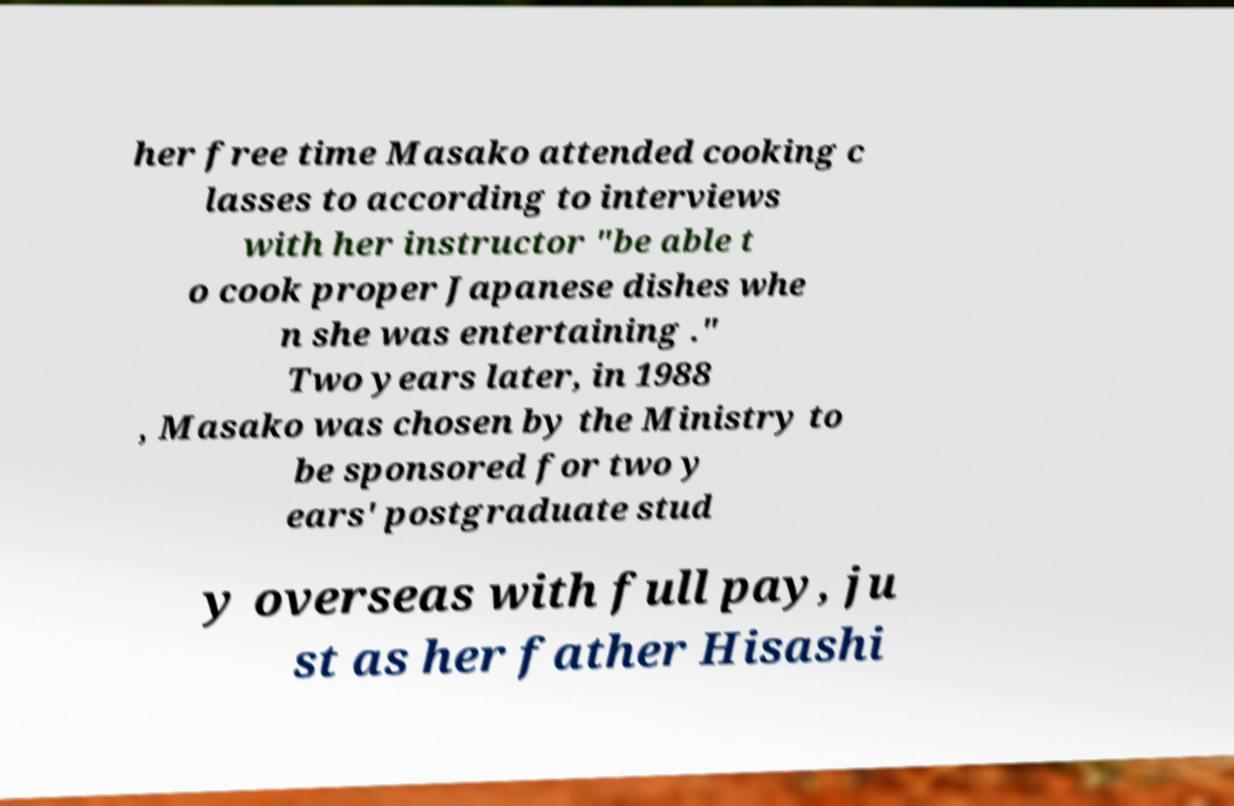What messages or text are displayed in this image? I need them in a readable, typed format. her free time Masako attended cooking c lasses to according to interviews with her instructor "be able t o cook proper Japanese dishes whe n she was entertaining ." Two years later, in 1988 , Masako was chosen by the Ministry to be sponsored for two y ears' postgraduate stud y overseas with full pay, ju st as her father Hisashi 